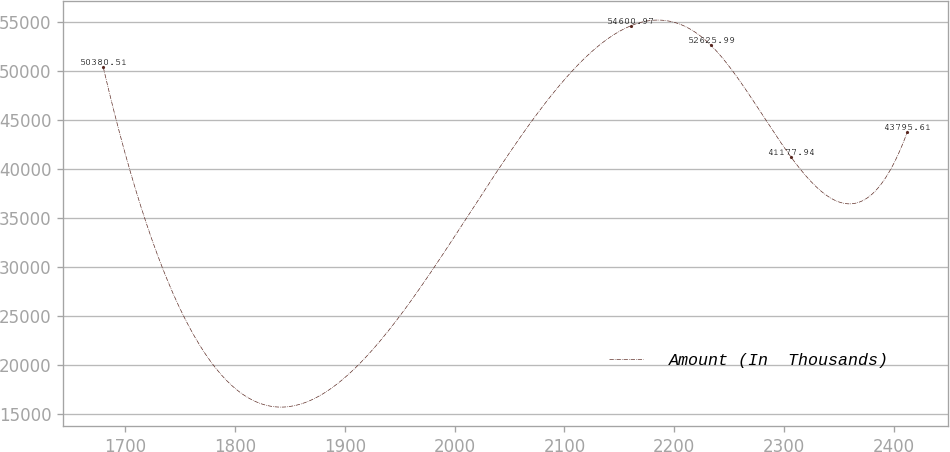Convert chart. <chart><loc_0><loc_0><loc_500><loc_500><line_chart><ecel><fcel>Amount (In  Thousands)<nl><fcel>1680.03<fcel>50380.5<nl><fcel>2160.2<fcel>54601<nl><fcel>2233.43<fcel>52626<nl><fcel>2306.66<fcel>41177.9<nl><fcel>2412.34<fcel>43795.6<nl></chart> 